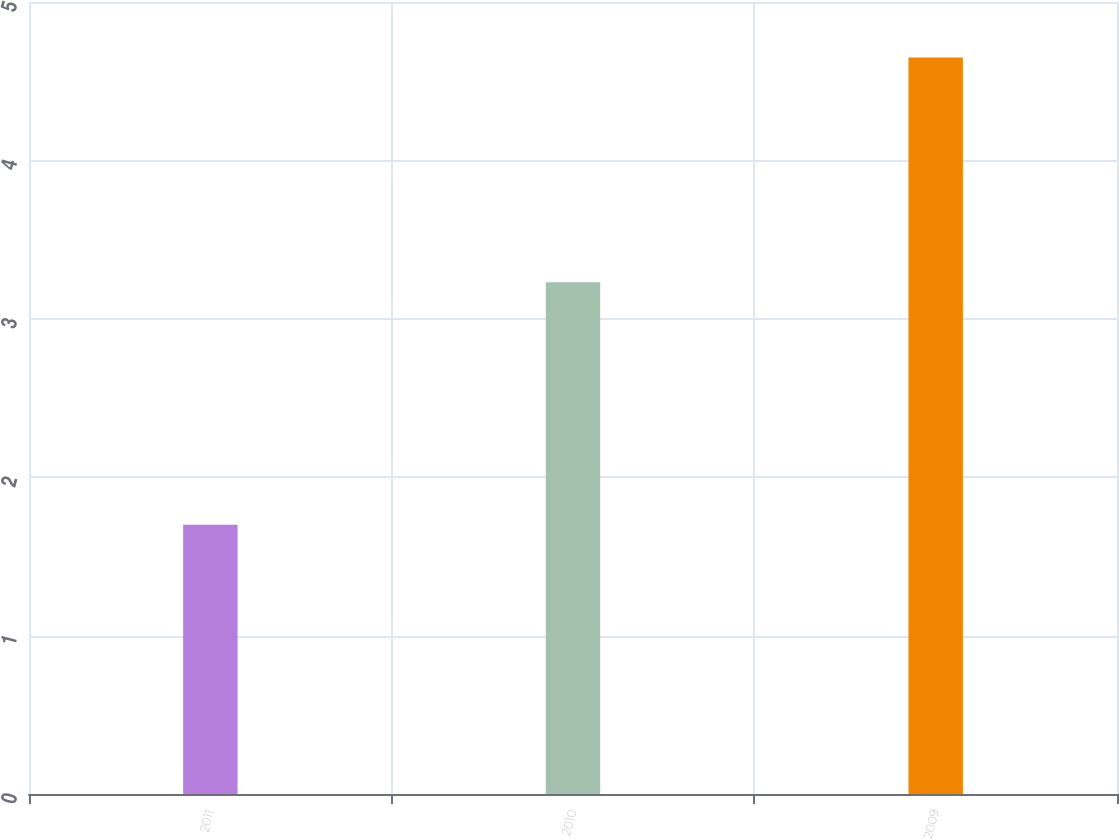<chart> <loc_0><loc_0><loc_500><loc_500><bar_chart><fcel>2011<fcel>2010<fcel>2009<nl><fcel>1.7<fcel>3.23<fcel>4.65<nl></chart> 